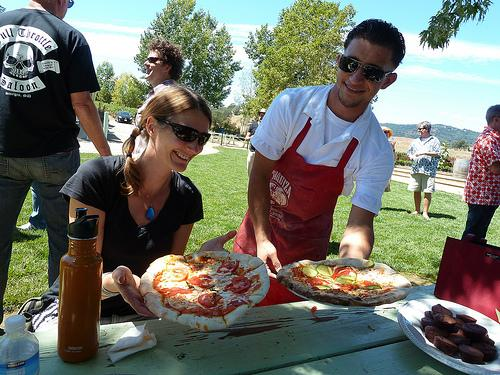What kind of dessert is on the plate? There is a plate of brownies on the table. What is the woman holding in her hands? The woman is holding a pizza with tomatoes and cheese on it. Count the number of people in the image and what each person is holding. There are two people in the image, a woman holding a pizza and a man holding a pizza. What kind of pizza is being held by the young woman? The young woman is holding a cheese pizza with large tomatoes on it. What are the common features between the woman and the man in the photo? Both the woman and the man are wearing sunglasses and holding pizzas. How many sunglasses are mentioned in the descriptions and what are their locations? There are two mentions of sunglasses - one on a girl's face and another on a man's face. Can you tell me what the woman is wearing on her shirt? The woman is wearing a black v-neck shirt. Are there any trees nearby the picnic table? Yes, there are tree leaves hanging near the picnic table. Describe the water bottle in the image. The water bottle is large, burnt orange, and sitting on the picnic table. What is the color of the gem on the necklace? The gem on the necklace is blue. 